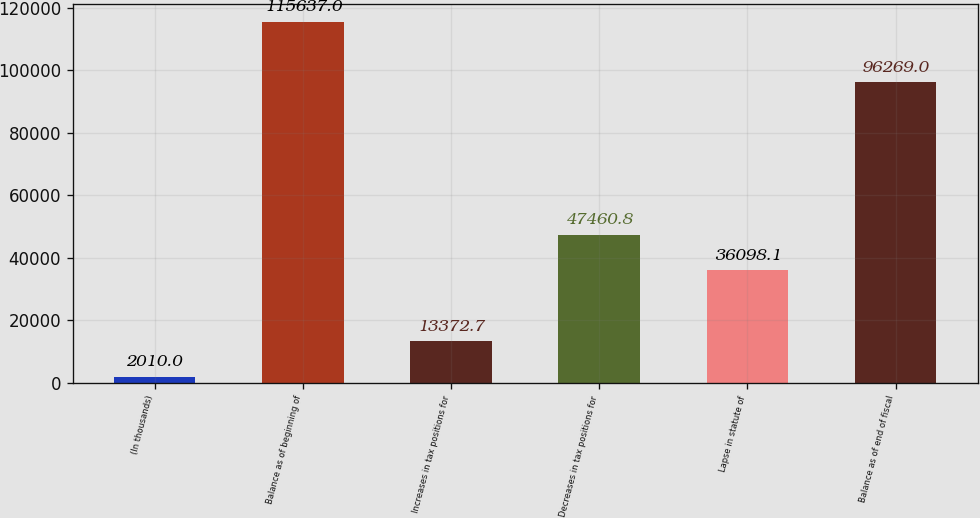<chart> <loc_0><loc_0><loc_500><loc_500><bar_chart><fcel>(In thousands)<fcel>Balance as of beginning of<fcel>Increases in tax positions for<fcel>Decreases in tax positions for<fcel>Lapse in statute of<fcel>Balance as of end of fiscal<nl><fcel>2010<fcel>115637<fcel>13372.7<fcel>47460.8<fcel>36098.1<fcel>96269<nl></chart> 